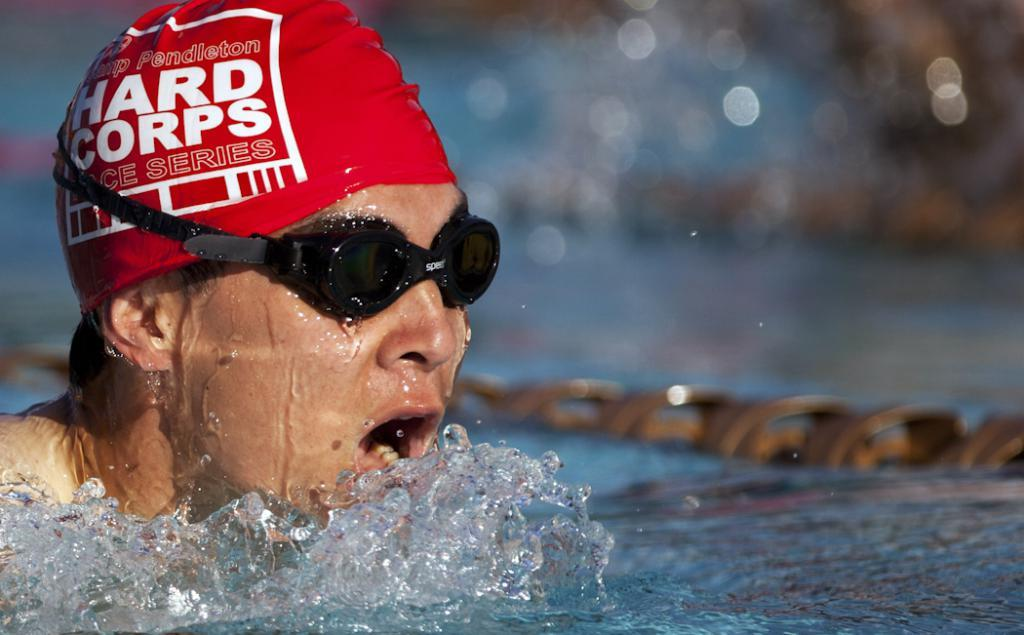What is the person in the image doing? The person is in the water. Can you describe the person's appearance? The person is wearing spectacles. What type of plastic is the deer chewing on in the image? There is no deer or plastic present in the image; it only features a person in the water wearing spectacles. 